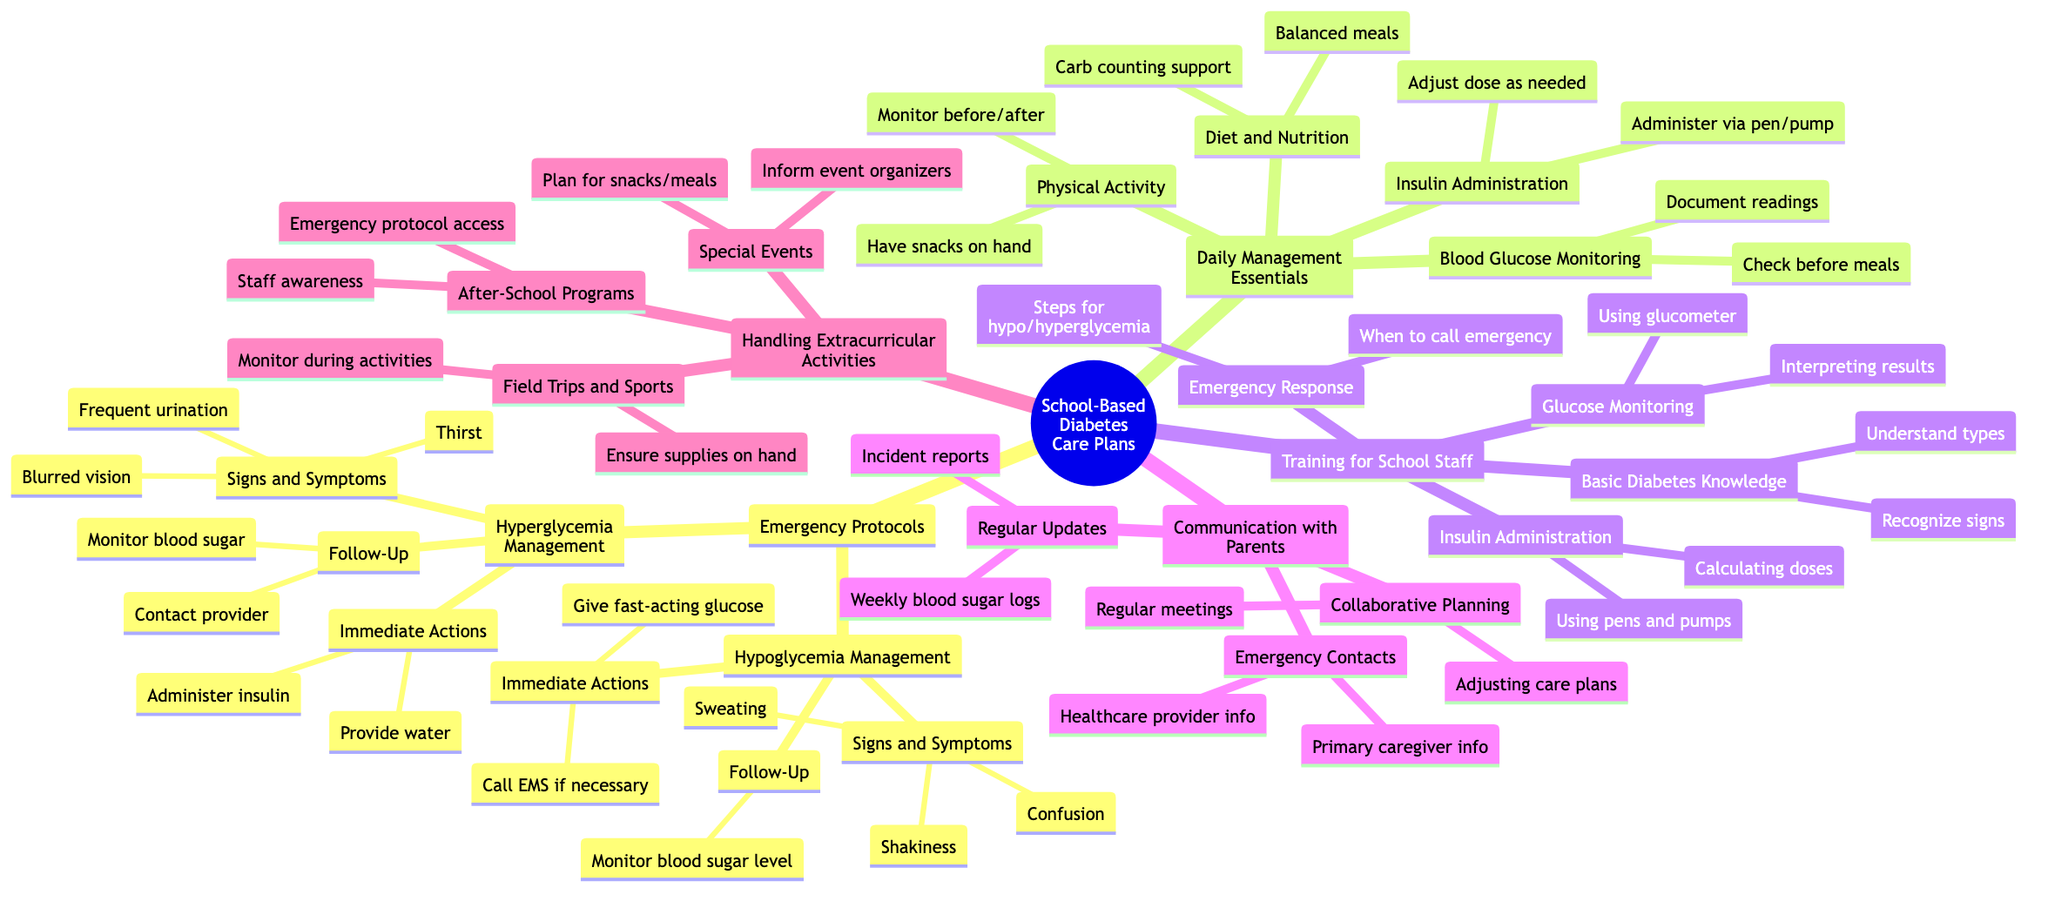What are the immediate actions for hypoglycemia management? The diagram specifies two immediate actions for hypoglycemia: give fast-acting glucose and call EMS if necessary. These actions are listed under the "Immediate Actions" node of the "Hypoglycemia Management" section.
Answer: Give fast-acting glucose, call EMS if necessary How many signs and symptoms are listed for hyperglycemia? The "Signs and Symptoms" section of "Hyperglycemia Management" includes three specific signs: frequent urination, thirst, and blurred vision. By counting these listed symptoms, the answer can be found.
Answer: 3 What should be monitored before and after physical activity? The diagram clearly indicates that blood sugar should be monitored before and after exercise, as listed under the "Physical Activity" section of "Daily Management Essentials."
Answer: Blood sugar What kind of training is required for school staff regarding glucose monitoring? The "Glucose Monitoring" section under "Training for School Staff" outlines that staff receive training on using a glucometer and interpreting results. This information is specific to the training necessary for accurate glucose monitoring.
Answer: Using glucometer, interpreting results How are parents involved in communication regarding diabetes care? The "Communication with Parents" section highlights several methods of involvement, including regular updates, emergency contacts, and collaborative planning. These factors indicate how communication is structured between the school and parents.
Answer: Regular updates, emergency contacts, collaborative planning What supplies are needed during field trips? The diagram states that during field trips, it is essential to ensure that supplies are on hand for diabetes management. This requirement is explicitly mentioned under the "Field Trips and Sports" section of "Handling Extracurricular Activities."
Answer: Supplies on hand What are the follow-up actions after hyperglycemia management? Following the management of hyperglycemia, the diagram indicates two follow-up actions: monitor blood sugar level and contact healthcare provider. These actions are specified together under the "Follow-Up" node of the "Hyperglycemia Management" section.
Answer: Monitor blood sugar level, contact healthcare provider Which part of the diagram deals with insulin administration? The "Insulin Administration" section in "Daily Management Essentials" directly addresses this topic, discussing the methods of administering insulin and adjusting doses as needed. This section is explicitly dedicated to the process of insulin management.
Answer: Insulin Administration What is emphasized for after-school program staff? The diagram notes that staff awareness and accessible emergency protocol are emphasized for after-school programs, ensuring that all staff members are informed and prepared to respond to emergencies.
Answer: Staff awareness, emergency protocol accessible 